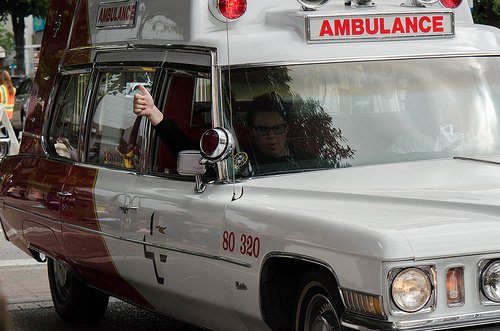<image>
Is the thumb to the left of the ambulance? Yes. From this viewpoint, the thumb is positioned to the left side relative to the ambulance. Is there a person behind the light? Yes. From this viewpoint, the person is positioned behind the light, with the light partially or fully occluding the person. Is the woman in the car? Yes. The woman is contained within or inside the car, showing a containment relationship. 